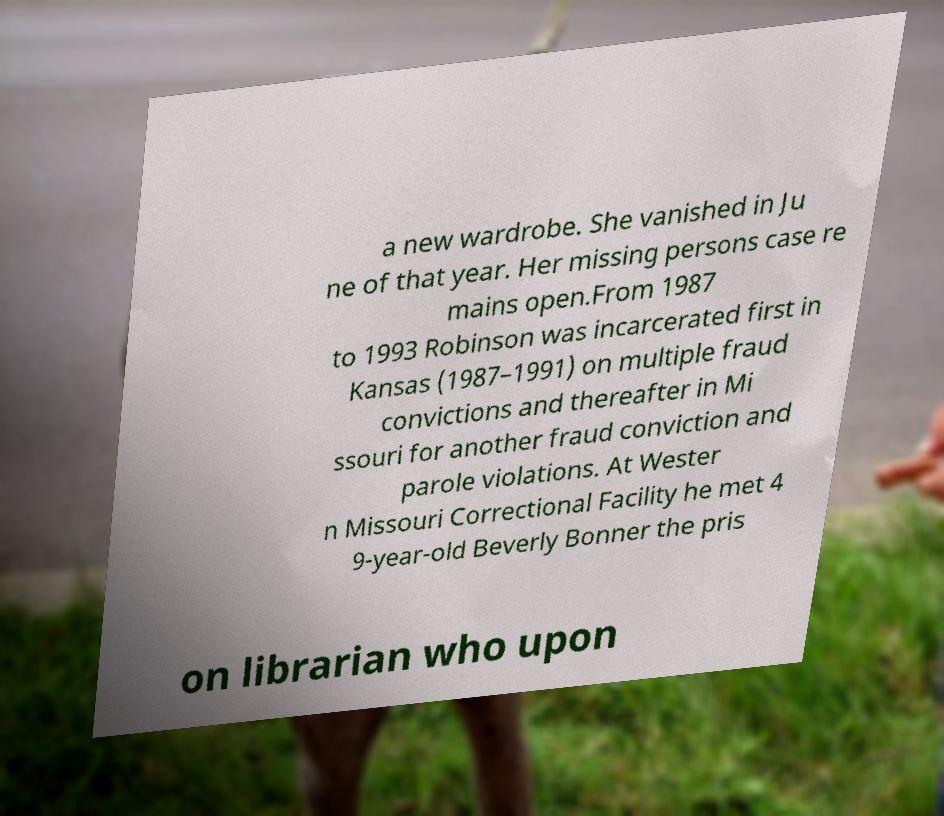Can you accurately transcribe the text from the provided image for me? a new wardrobe. She vanished in Ju ne of that year. Her missing persons case re mains open.From 1987 to 1993 Robinson was incarcerated first in Kansas (1987–1991) on multiple fraud convictions and thereafter in Mi ssouri for another fraud conviction and parole violations. At Wester n Missouri Correctional Facility he met 4 9-year-old Beverly Bonner the pris on librarian who upon 